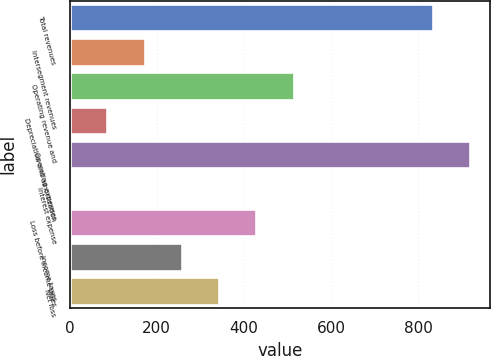Convert chart to OTSL. <chart><loc_0><loc_0><loc_500><loc_500><bar_chart><fcel>Total revenues<fcel>Intersegment revenues<fcel>Operating revenue and<fcel>Depreciation and amortization<fcel>Operating expenses<fcel>Interest expense<fcel>Loss before income taxes<fcel>Income taxes<fcel>Net loss<nl><fcel>834<fcel>172.2<fcel>514.6<fcel>86.6<fcel>919.6<fcel>1<fcel>429<fcel>257.8<fcel>343.4<nl></chart> 